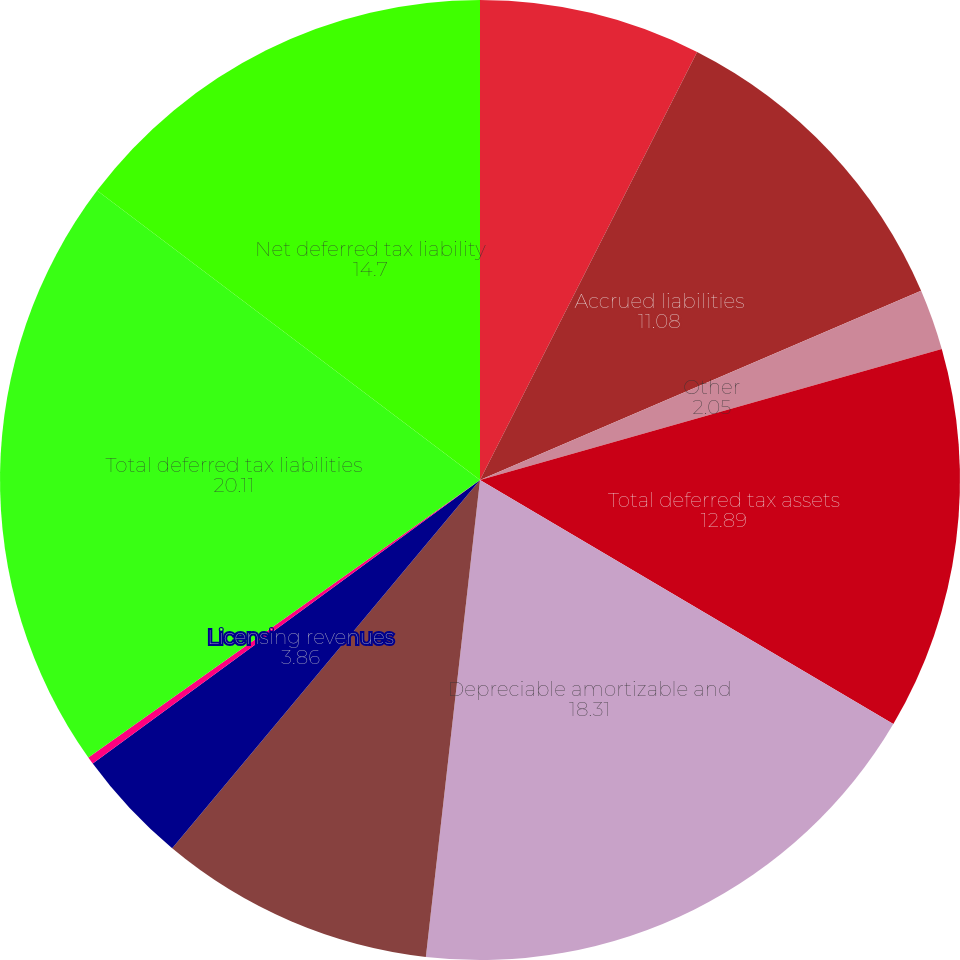Convert chart to OTSL. <chart><loc_0><loc_0><loc_500><loc_500><pie_chart><fcel>Net operating losses and tax<fcel>Accrued liabilities<fcel>Other<fcel>Total deferred tax assets<fcel>Depreciable amortizable and<fcel>Investment in US entities<fcel>Licensing revenues<fcel>Investment in foreign entities<fcel>Total deferred tax liabilities<fcel>Net deferred tax liability<nl><fcel>7.47%<fcel>11.08%<fcel>2.05%<fcel>12.89%<fcel>18.31%<fcel>9.28%<fcel>3.86%<fcel>0.25%<fcel>20.11%<fcel>14.7%<nl></chart> 